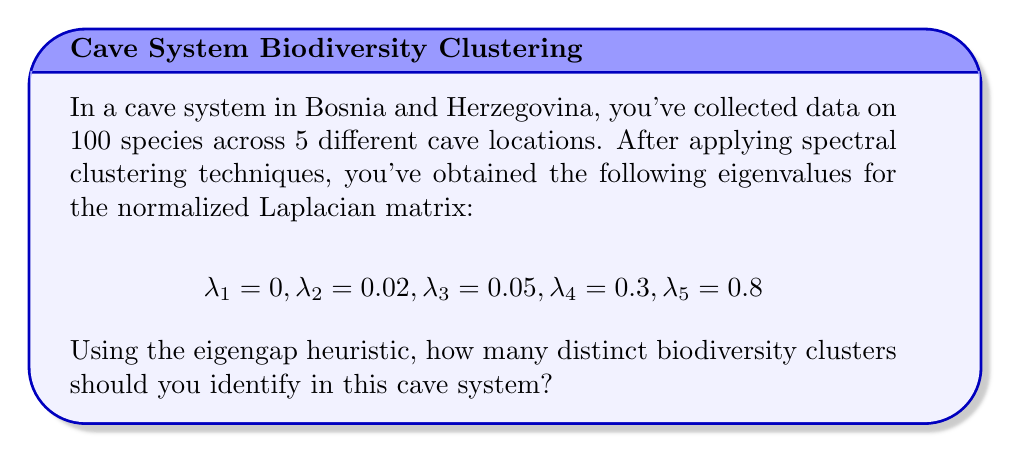Provide a solution to this math problem. To determine the number of clusters using the eigengap heuristic in spectral clustering, we follow these steps:

1. Sort the eigenvalues in ascending order (which they already are in this case):
   $$\lambda_1 = 0 < \lambda_2 = 0.02 < \lambda_3 = 0.05 < \lambda_4 = 0.3 < \lambda_5 = 0.8$$

2. Calculate the differences (gaps) between consecutive eigenvalues:
   $$\text{Gap}_1 = \lambda_2 - \lambda_1 = 0.02 - 0 = 0.02$$
   $$\text{Gap}_2 = \lambda_3 - \lambda_2 = 0.05 - 0.02 = 0.03$$
   $$\text{Gap}_3 = \lambda_4 - \lambda_3 = 0.3 - 0.05 = 0.25$$
   $$\text{Gap}_4 = \lambda_5 - \lambda_4 = 0.8 - 0.3 = 0.5$$

3. Identify the largest gap. In this case, it's $\text{Gap}_4 = 0.5$.

4. The number of clusters is determined by the index of the largest gap. Since the largest gap is $\text{Gap}_4$, we conclude that there are 4 distinct biodiversity clusters in the cave system.

This result suggests that despite having data from 5 different cave locations, the spectral clustering analysis reveals 4 distinct biodiversity patterns or communities within the cave system.
Answer: 4 clusters 